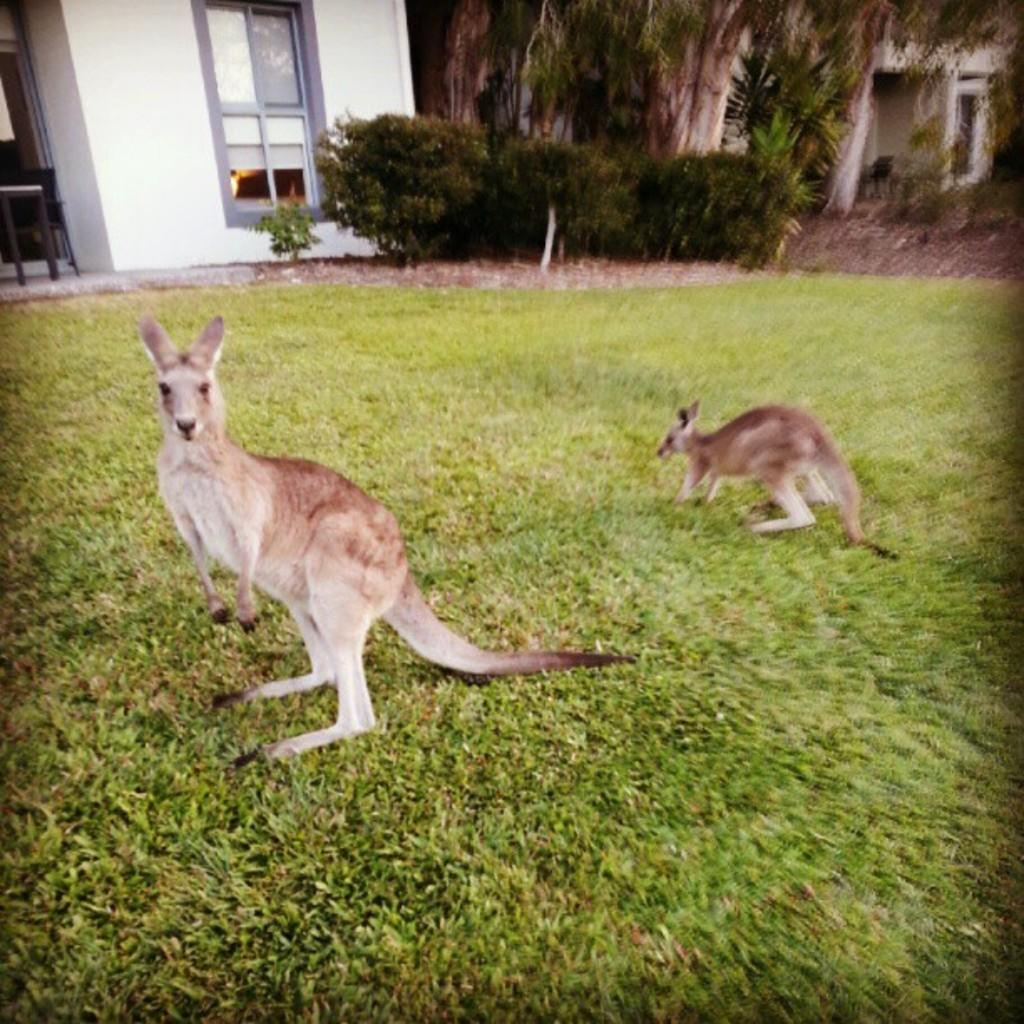What can be seen in the foreground of the image? There are two animals standing on the ground in the image. What is visible in the background of the image? There is a group of trees, a building with a window, and plants in the background of the image. What word is written on the stove in the image? There is no stove present in the image, so it is not possible to answer that question. 